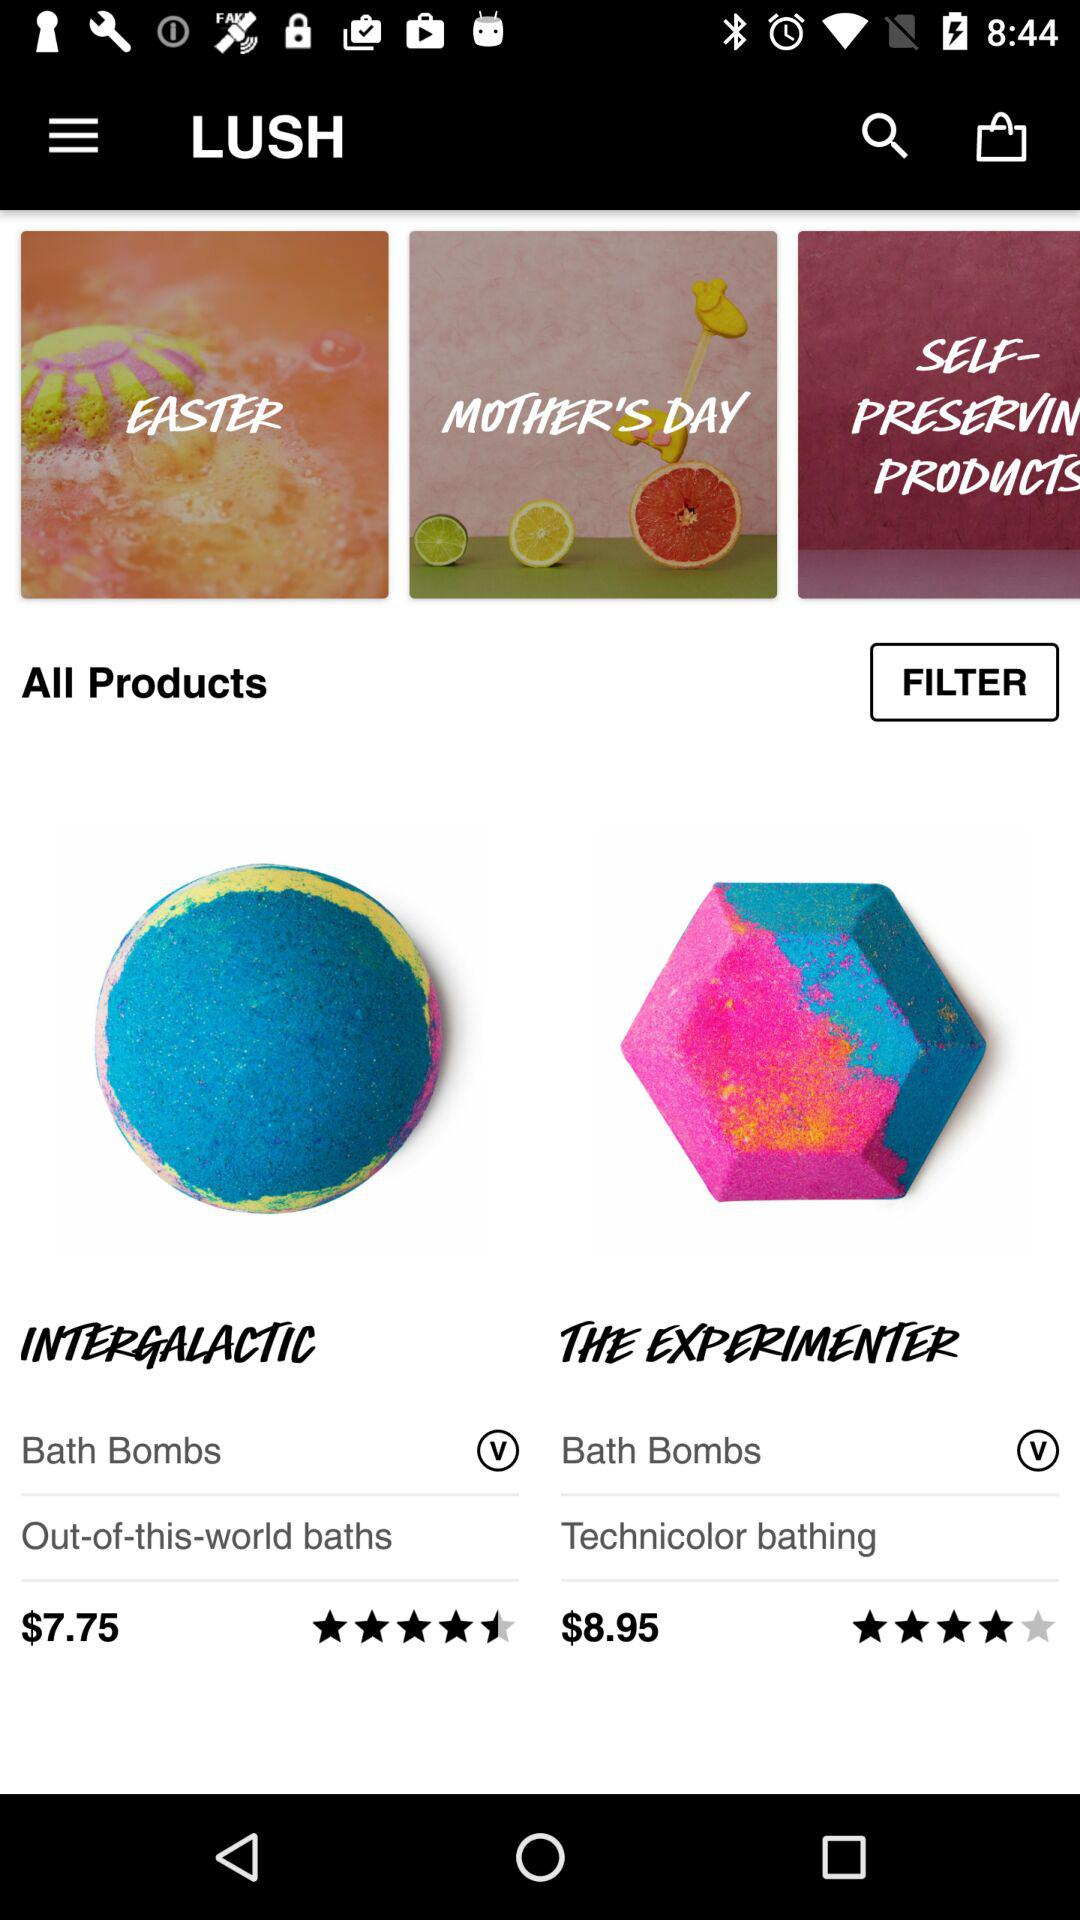What is the price of the "INTERGALACTIC"? The price of the "INTERGALACTIC" is $7.75. 